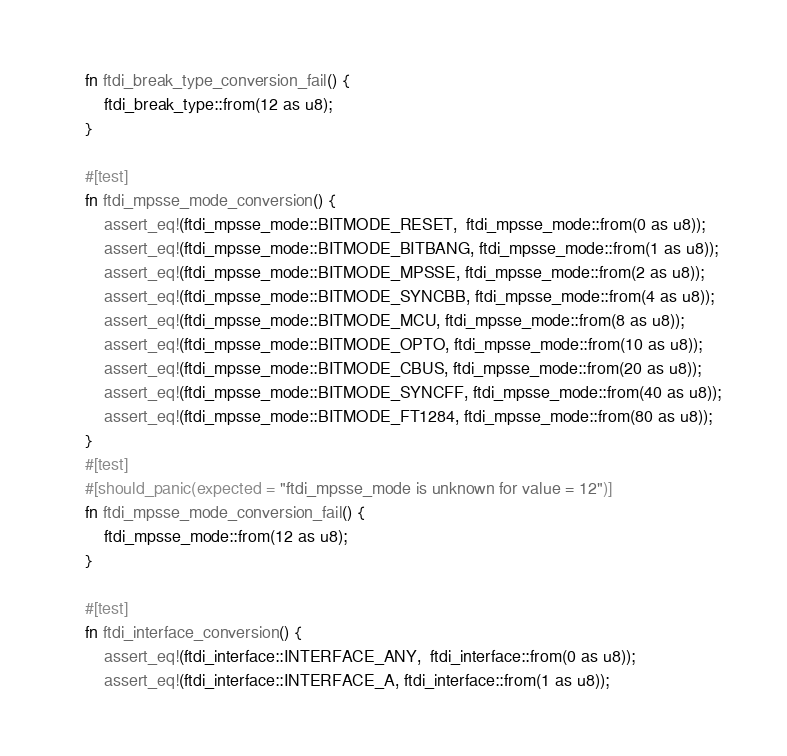<code> <loc_0><loc_0><loc_500><loc_500><_Rust_>    fn ftdi_break_type_conversion_fail() {
        ftdi_break_type::from(12 as u8);
    }

    #[test]
    fn ftdi_mpsse_mode_conversion() {
        assert_eq!(ftdi_mpsse_mode::BITMODE_RESET,  ftdi_mpsse_mode::from(0 as u8));
        assert_eq!(ftdi_mpsse_mode::BITMODE_BITBANG, ftdi_mpsse_mode::from(1 as u8));
        assert_eq!(ftdi_mpsse_mode::BITMODE_MPSSE, ftdi_mpsse_mode::from(2 as u8));
        assert_eq!(ftdi_mpsse_mode::BITMODE_SYNCBB, ftdi_mpsse_mode::from(4 as u8));
        assert_eq!(ftdi_mpsse_mode::BITMODE_MCU, ftdi_mpsse_mode::from(8 as u8));
        assert_eq!(ftdi_mpsse_mode::BITMODE_OPTO, ftdi_mpsse_mode::from(10 as u8));
        assert_eq!(ftdi_mpsse_mode::BITMODE_CBUS, ftdi_mpsse_mode::from(20 as u8));
        assert_eq!(ftdi_mpsse_mode::BITMODE_SYNCFF, ftdi_mpsse_mode::from(40 as u8));
        assert_eq!(ftdi_mpsse_mode::BITMODE_FT1284, ftdi_mpsse_mode::from(80 as u8));
    }
    #[test]
    #[should_panic(expected = "ftdi_mpsse_mode is unknown for value = 12")]
    fn ftdi_mpsse_mode_conversion_fail() {
        ftdi_mpsse_mode::from(12 as u8);
    }

    #[test]
    fn ftdi_interface_conversion() {
        assert_eq!(ftdi_interface::INTERFACE_ANY,  ftdi_interface::from(0 as u8));
        assert_eq!(ftdi_interface::INTERFACE_A, ftdi_interface::from(1 as u8));</code> 